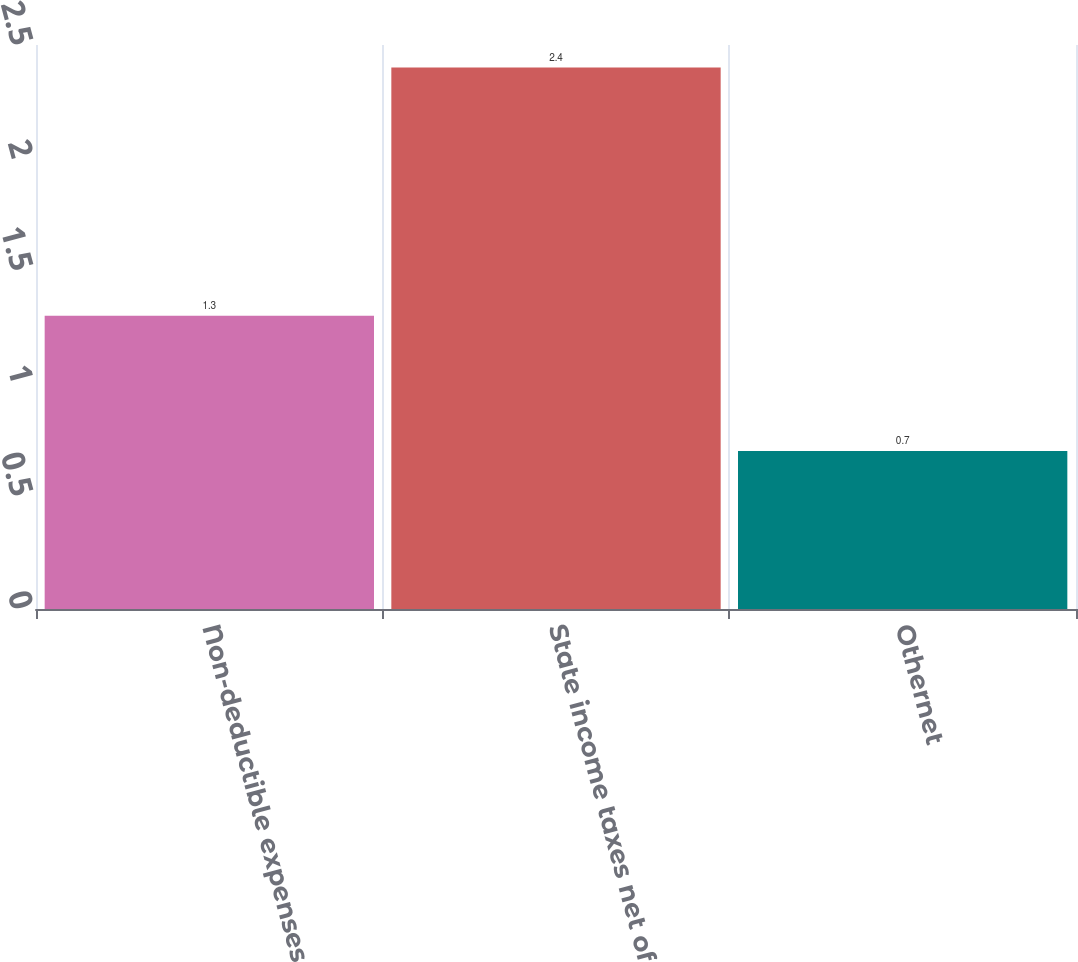<chart> <loc_0><loc_0><loc_500><loc_500><bar_chart><fcel>Non-deductible expenses<fcel>State income taxes net of<fcel>Othernet<nl><fcel>1.3<fcel>2.4<fcel>0.7<nl></chart> 